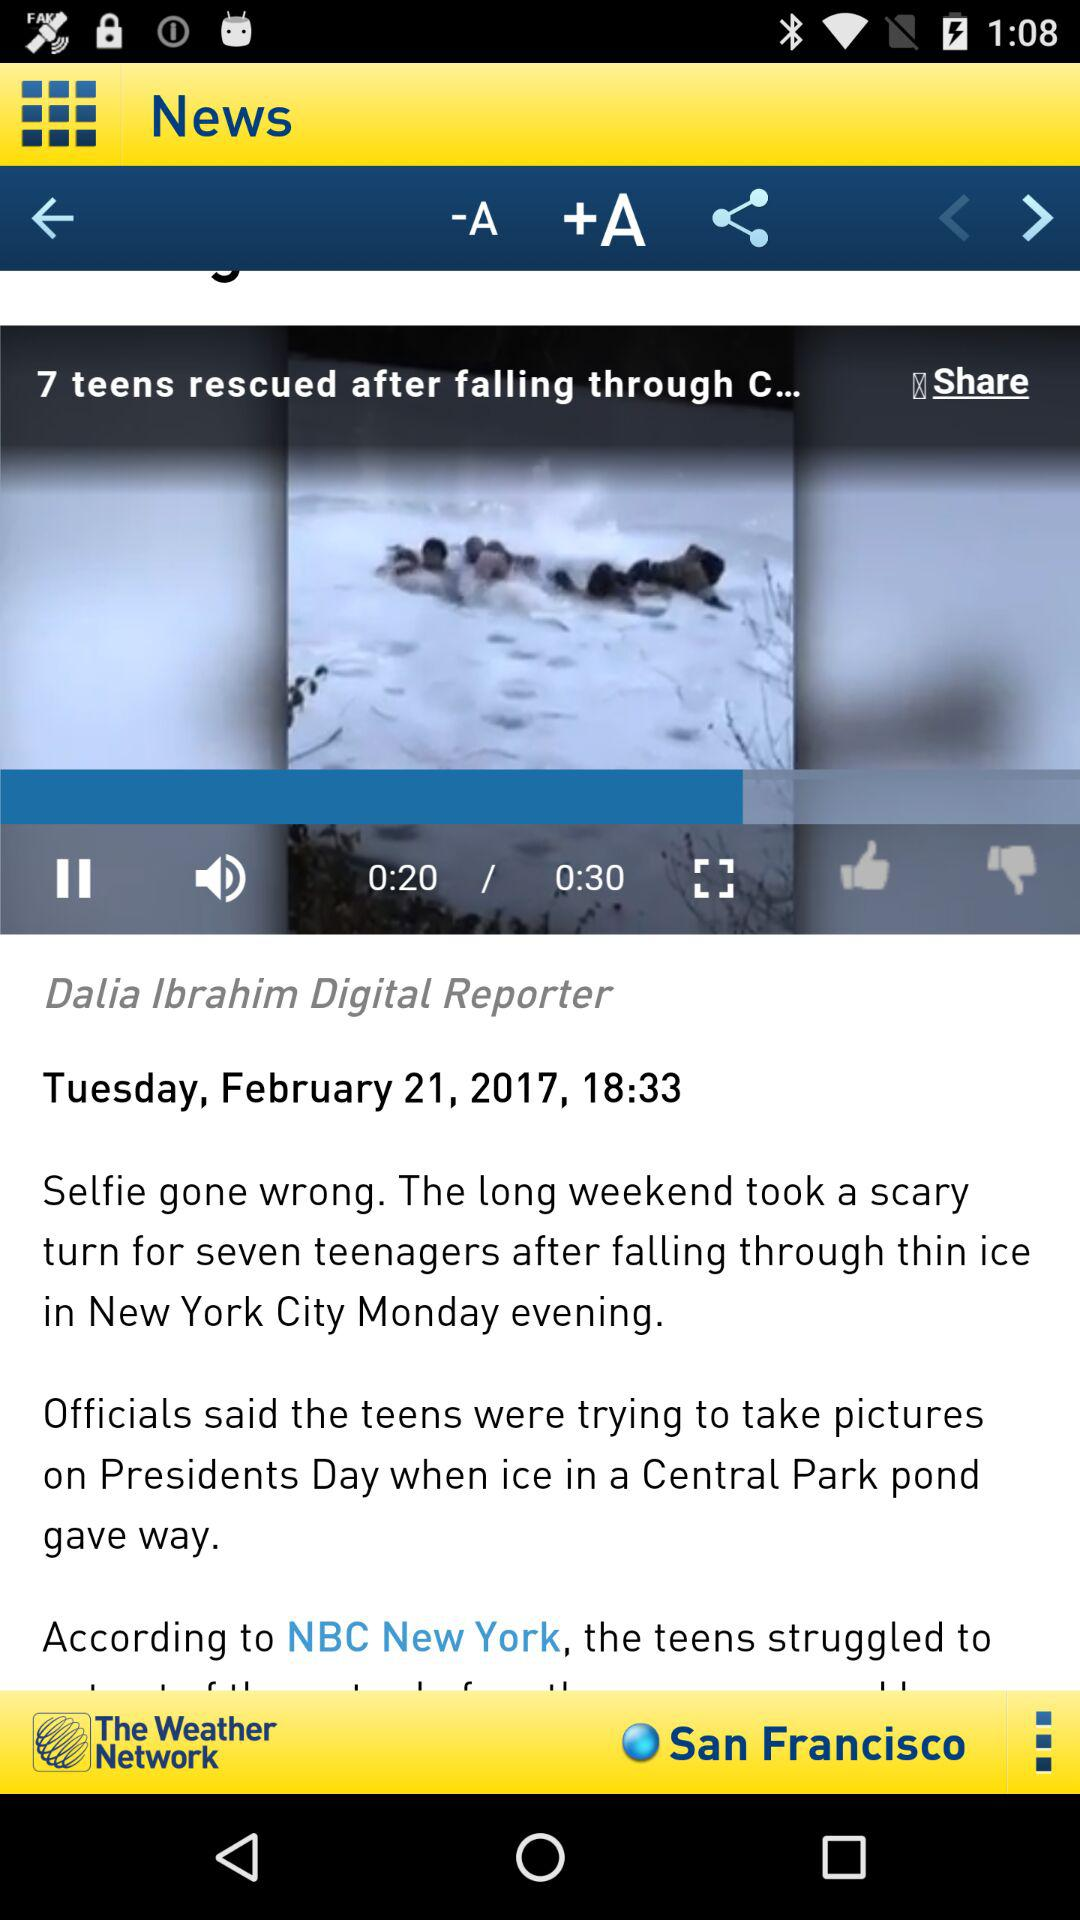How many more seconds are left in the video than have already passed?
Answer the question using a single word or phrase. 10 